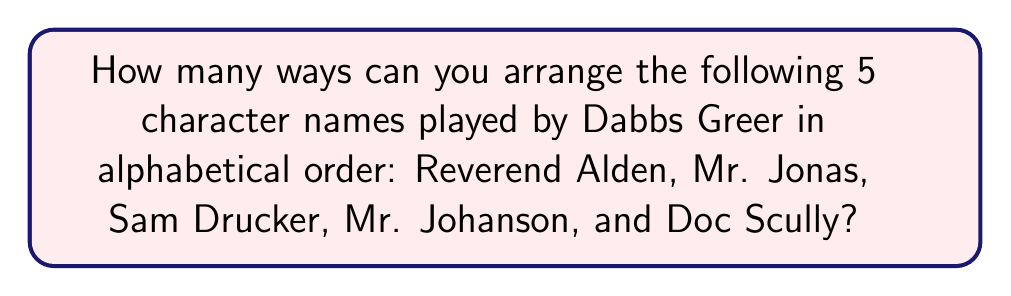Help me with this question. To solve this problem, we need to follow these steps:

1. First, let's arrange the names in alphabetical order:
   Doc Scully, Mr. Johanson, Mr. Jonas, Reverend Alden, Sam Drucker

2. Now, we need to count how many ways we can arrange these names while maintaining their alphabetical order. This is equivalent to finding the number of permutations where the relative order of the names remains the same.

3. In combinatorics, this type of problem is solved using the concept of combinations. We're essentially choosing positions for each name from the available slots, always maintaining their relative order.

4. The number of ways to do this is given by the formula:

   $$\binom{n}{k_1, k_2, ..., k_m}$$

   Where $n$ is the total number of positions (5 in this case), and $k_1, k_2, ..., k_m$ are the number of indistinguishable items in each group (1 for each name in this case, as each name is distinct).

5. In our case, this becomes:

   $$\binom{5}{1, 1, 1, 1, 1}$$

6. This multinomial coefficient can be calculated as:

   $$\frac{5!}{1! \cdot 1! \cdot 1! \cdot 1! \cdot 1!} = 5! = 5 \cdot 4 \cdot 3 \cdot 2 \cdot 1 = 120$$

Therefore, there are 120 ways to arrange these character names while maintaining alphabetical order.
Answer: 120 